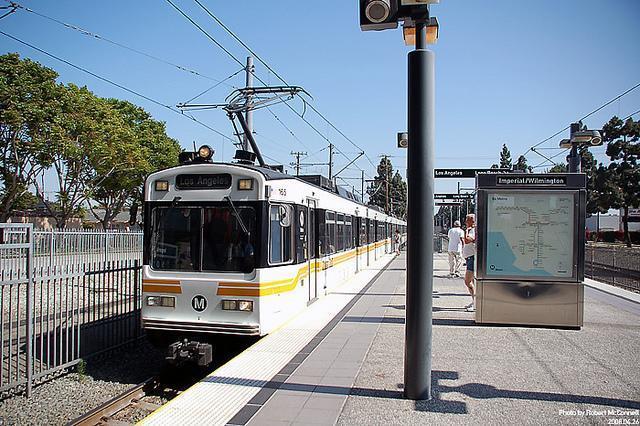How many maps are in the photo?
Give a very brief answer. 1. How many trains can be seen?
Give a very brief answer. 1. How many cars have a surfboard on the roof?
Give a very brief answer. 0. 